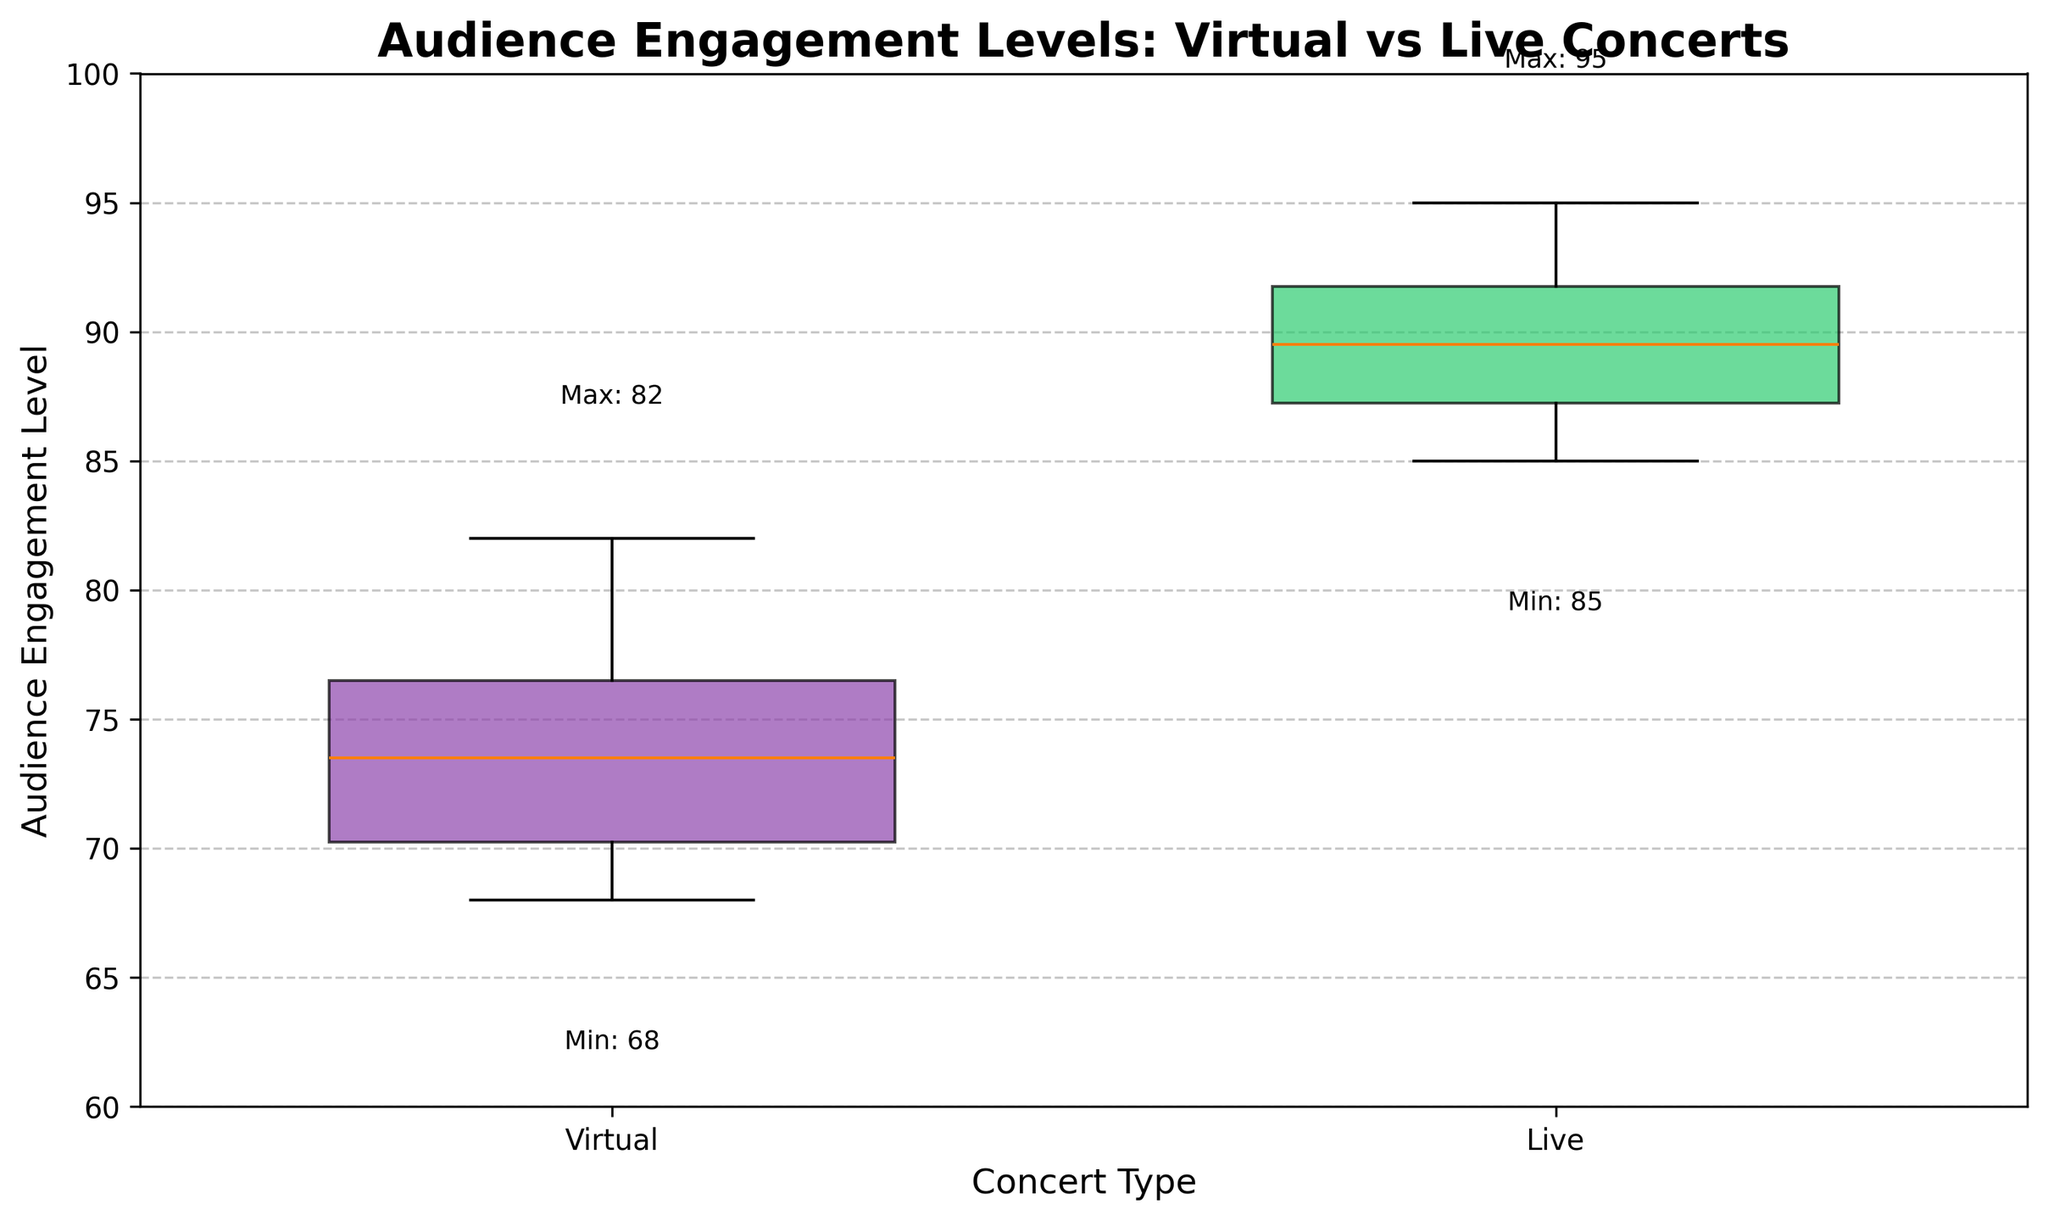what are the concert types shown in the figure? The figure has two groups represented on the x-axis. We can identify them from the labels directly under the x-axis. The labels indicate the two types of concerts being compared.
Answer: Virtual, Live What is the title of the plot? The title of the plot is typically located at the top center of the figure, indicated by a larger or bold font.
Answer: Audience Engagement Levels: Virtual vs Live Concerts What is the minimum audience engagement level for live concerts? The minimum value can be found by looking at the bottom end of the whisker or the text annotation indicating the "Min" value for the live concerts data points, corresponding to the 'Live' group in the box plot.
Answer: 85 Which concert type shows higher audience engagement levels on average? Examine the central tendency (median line) within the boxes. The box with a higher median line indicates a higher average engagement level. In this plot, the median line for the 'Live' group is higher than that for the 'Virtual' group.
Answer: Live What is the interquartile range (IQR) for the virtual concerts? The IQR is the range between the first quartile (Q1) and the third quartile (Q3) values, shown by the edges of the box. Identify the Q1 and Q3 values to compute the IQR for the 'Virtual' group.
Answer: Q3 (77) - Q1 (70) = 7 How do the whisker lengths compare between virtual and live concerts? The whiskers extend to represent the range of the data. Compare the lengths of the whiskers for both the 'Virtual' and 'Live' concert box plots to see which has a greater or smaller spread.
Answer: Virtual concerts have longer whiskers (indicating more spread) What is the highest engagement level recorded for virtual concerts? The highest value is noted at the top end of one of the whiskers or can be found by the text annotation showing the "Max" value for the virtual concerts.
Answer: 82 By how much do the engagement levels for live concerts exceed those of virtual concerts at their respective max points? The maximum engagement level for live concerts can be compared to that for virtual concerts using subtraction. The Max for live concerts is 95, and for virtual concerts it is 82.
Answer: 95 - 82 = 13 points Does either concert type show any outliers? Outliers are typically represented by individual points that fall outside the whiskers. Since the prompt data doesn't suggest any outliers explicitly and the visualization isn’t available, check if there are any plotted.
Answer: No outliers Which concert type has a broader interquartile range? Identify the edges of the box (Q1 and Q3) for each group and compare the IQRs determined for both 'Virtual' and 'Live' groups to see which one has a larger value. The calculation indicates a broader IQR for the live concerts (Q3-Q1).
Answer: Live concerts have a broader IQR 